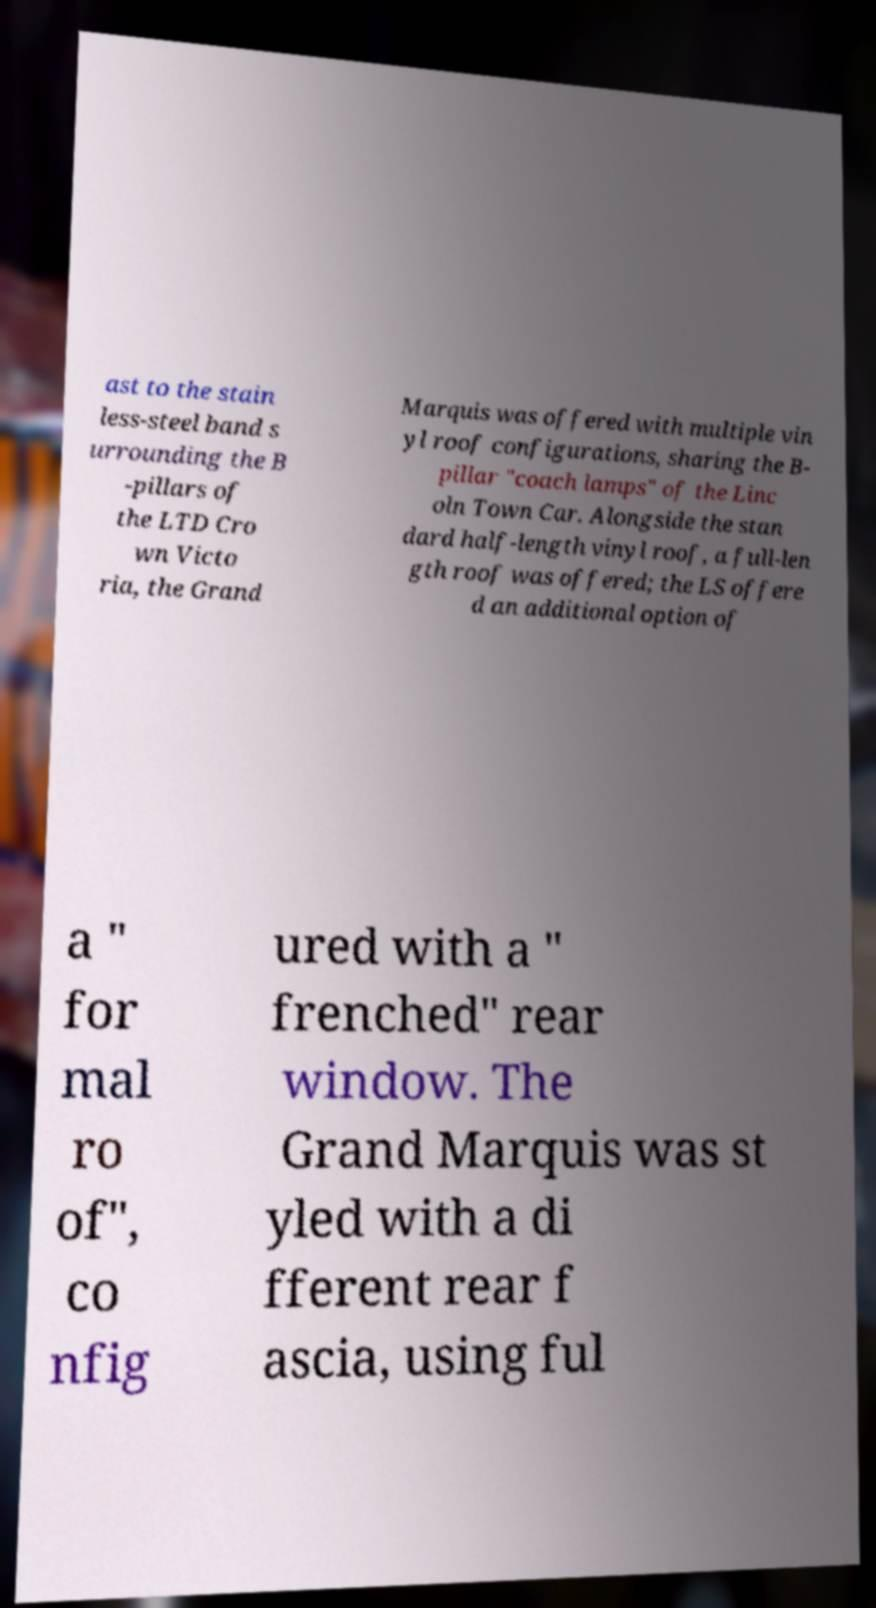Please identify and transcribe the text found in this image. ast to the stain less-steel band s urrounding the B -pillars of the LTD Cro wn Victo ria, the Grand Marquis was offered with multiple vin yl roof configurations, sharing the B- pillar "coach lamps" of the Linc oln Town Car. Alongside the stan dard half-length vinyl roof, a full-len gth roof was offered; the LS offere d an additional option of a " for mal ro of", co nfig ured with a " frenched" rear window. The Grand Marquis was st yled with a di fferent rear f ascia, using ful 